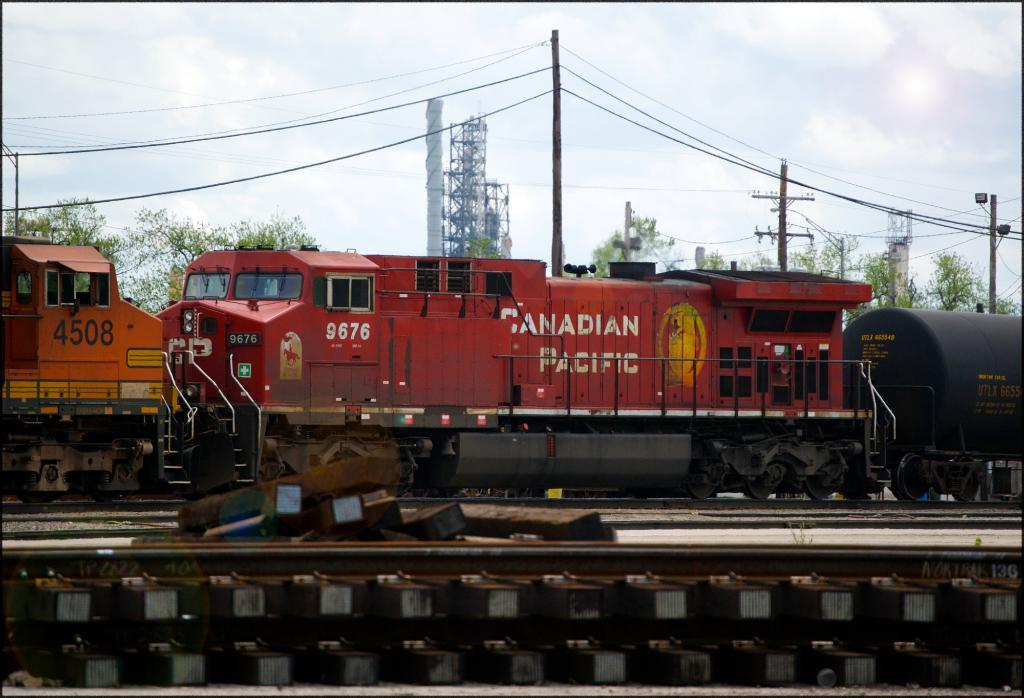What type of vehicles can be seen on the railway track in the image? There are trains on the railway track in the image. What structures are visible alongside the railway track? Electric poles are visible in the image. What type of plant life is present in the image? There is a tree in the image. What is visible in the background of the image? The sky is visible in the image, and clouds are present in the sky. What type of creature is responsible for maintaining the railway track in the image? There is no creature present in the image that is responsible for maintaining the railway track. 